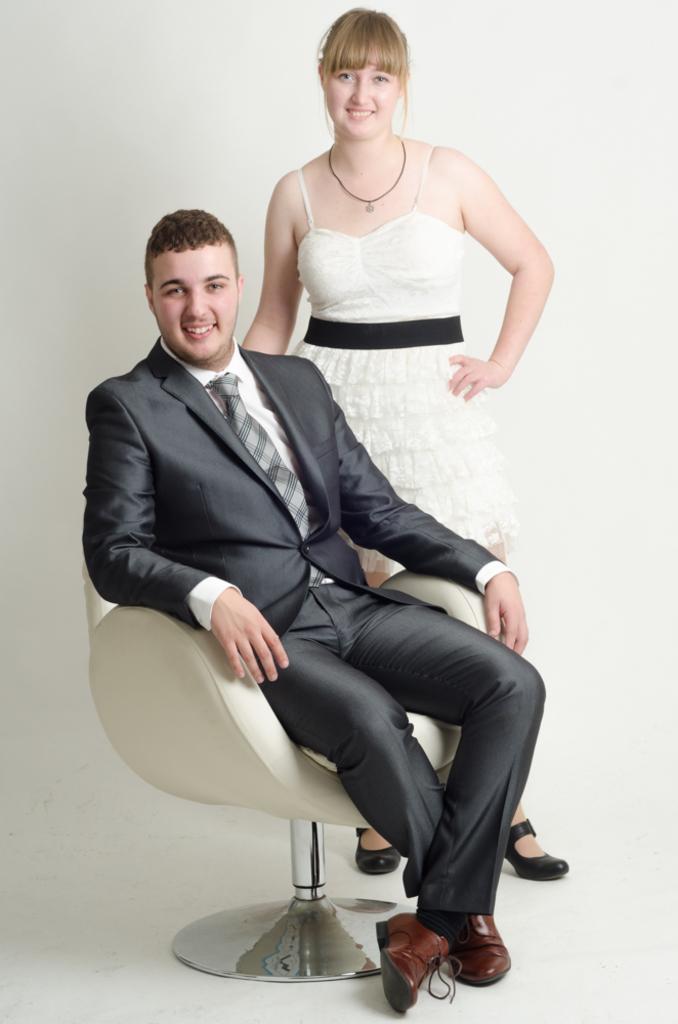Could you give a brief overview of what you see in this image? A couple are kissing to a camera in which woman is standing and the man is sitting in a chair. 